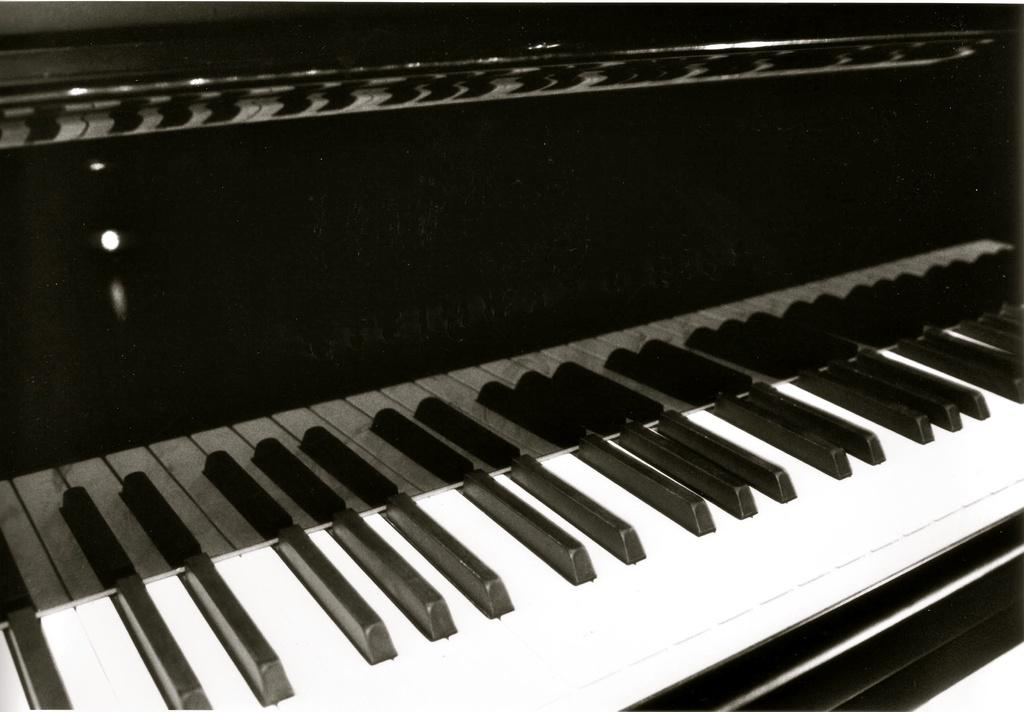What musical instrument is present in the image? There is a piano in the image. What are the keys on the piano like? The piano has black and white keys. What color is the piano box? The piano box is in black color. What type of weather can be seen in the image? There is no weather depicted in the image, as it features a piano with black and white keys and a black piano box. 